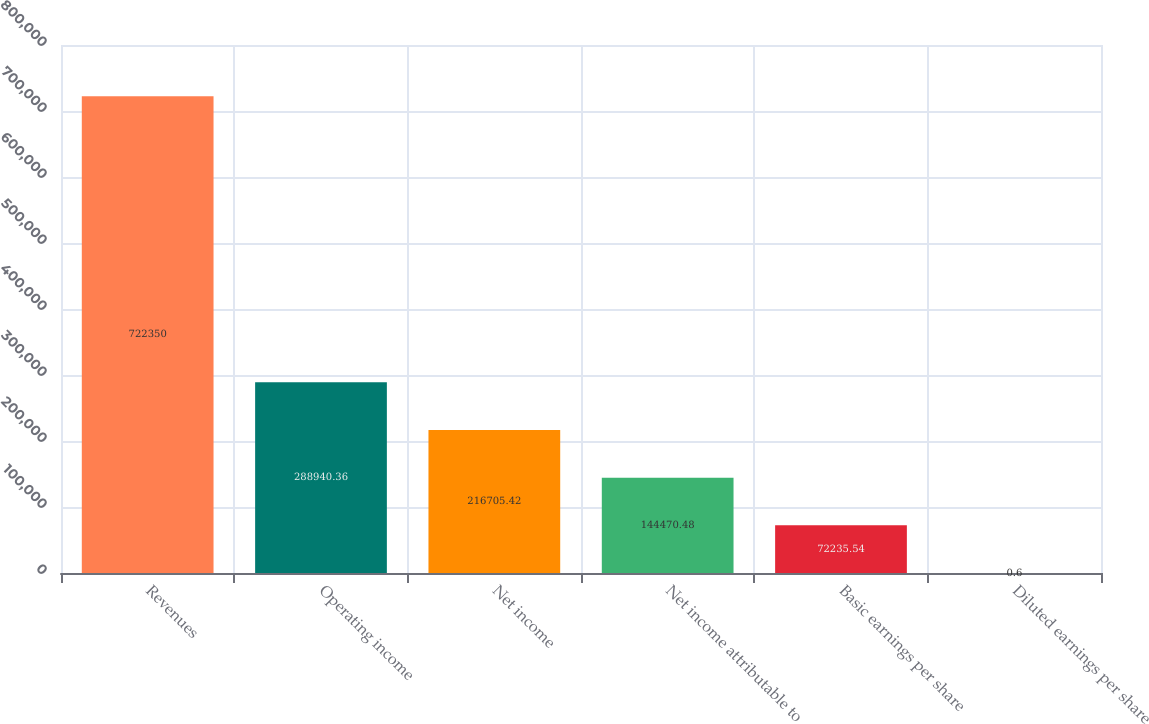<chart> <loc_0><loc_0><loc_500><loc_500><bar_chart><fcel>Revenues<fcel>Operating income<fcel>Net income<fcel>Net income attributable to<fcel>Basic earnings per share<fcel>Diluted earnings per share<nl><fcel>722350<fcel>288940<fcel>216705<fcel>144470<fcel>72235.5<fcel>0.6<nl></chart> 